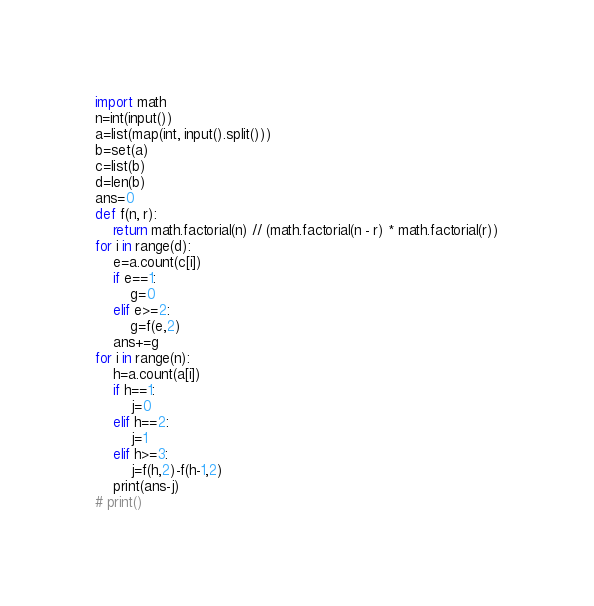<code> <loc_0><loc_0><loc_500><loc_500><_Python_>import math
n=int(input())
a=list(map(int, input().split()))
b=set(a)
c=list(b)
d=len(b)
ans=0
def f(n, r):
    return math.factorial(n) // (math.factorial(n - r) * math.factorial(r))
for i in range(d):
    e=a.count(c[i])
    if e==1:
        g=0
    elif e>=2:
        g=f(e,2)
    ans+=g
for i in range(n):
    h=a.count(a[i])
    if h==1:
        j=0
    elif h==2:
        j=1
    elif h>=3:
        j=f(h,2)-f(h-1,2)
    print(ans-j)
# print()
</code> 